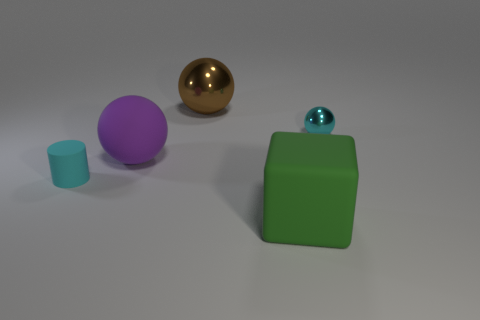What color is the large ball that is behind the big purple rubber thing?
Provide a succinct answer. Brown. There is a big matte object in front of the small cyan matte object; is its shape the same as the rubber thing to the left of the purple rubber ball?
Offer a very short reply. No. Are there any brown cylinders of the same size as the green matte thing?
Make the answer very short. No. What is the material of the tiny object that is to the right of the purple matte thing?
Your response must be concise. Metal. Is the small cyan thing that is on the right side of the purple rubber thing made of the same material as the brown ball?
Keep it short and to the point. Yes. Are any purple matte spheres visible?
Make the answer very short. Yes. What is the color of the big ball that is the same material as the green cube?
Provide a short and direct response. Purple. The sphere that is to the right of the large green rubber object on the right side of the small cyan object that is left of the matte cube is what color?
Your response must be concise. Cyan. Is the size of the cyan shiny object the same as the cyan thing in front of the big purple thing?
Ensure brevity in your answer.  Yes. What number of things are either tiny things that are to the left of the large metallic thing or big things that are behind the small metallic thing?
Your answer should be compact. 2. 